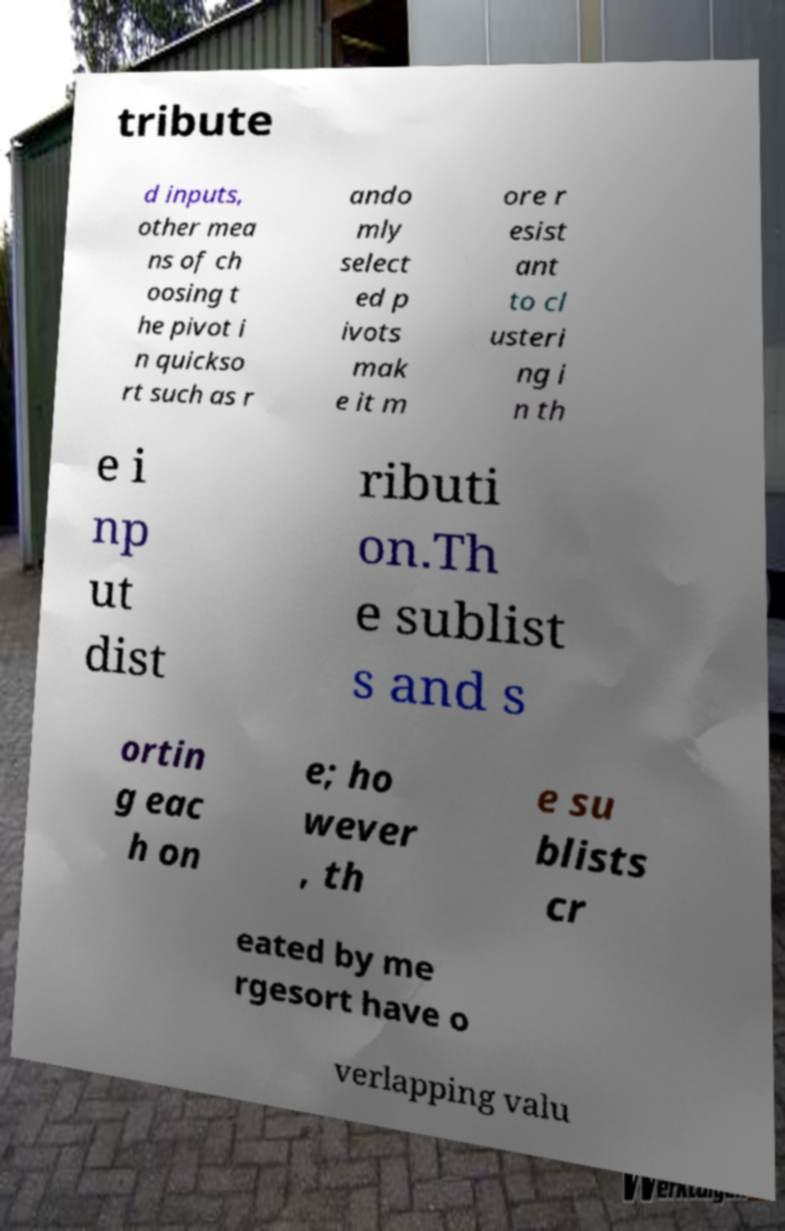Can you accurately transcribe the text from the provided image for me? tribute d inputs, other mea ns of ch oosing t he pivot i n quickso rt such as r ando mly select ed p ivots mak e it m ore r esist ant to cl usteri ng i n th e i np ut dist ributi on.Th e sublist s and s ortin g eac h on e; ho wever , th e su blists cr eated by me rgesort have o verlapping valu 